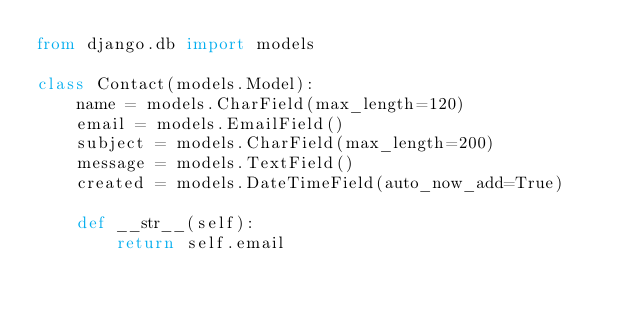<code> <loc_0><loc_0><loc_500><loc_500><_Python_>from django.db import models

class Contact(models.Model):
    name = models.CharField(max_length=120)
    email = models.EmailField()
    subject = models.CharField(max_length=200)
    message = models.TextField()
    created = models.DateTimeField(auto_now_add=True)

    def __str__(self):
        return self.email</code> 